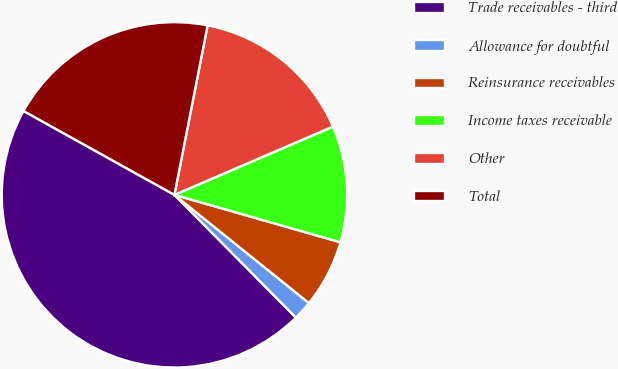Convert chart to OTSL. <chart><loc_0><loc_0><loc_500><loc_500><pie_chart><fcel>Trade receivables - third<fcel>Allowance for doubtful<fcel>Reinsurance receivables<fcel>Income taxes receivable<fcel>Other<fcel>Total<nl><fcel>45.49%<fcel>1.8%<fcel>6.35%<fcel>10.9%<fcel>15.45%<fcel>20.0%<nl></chart> 